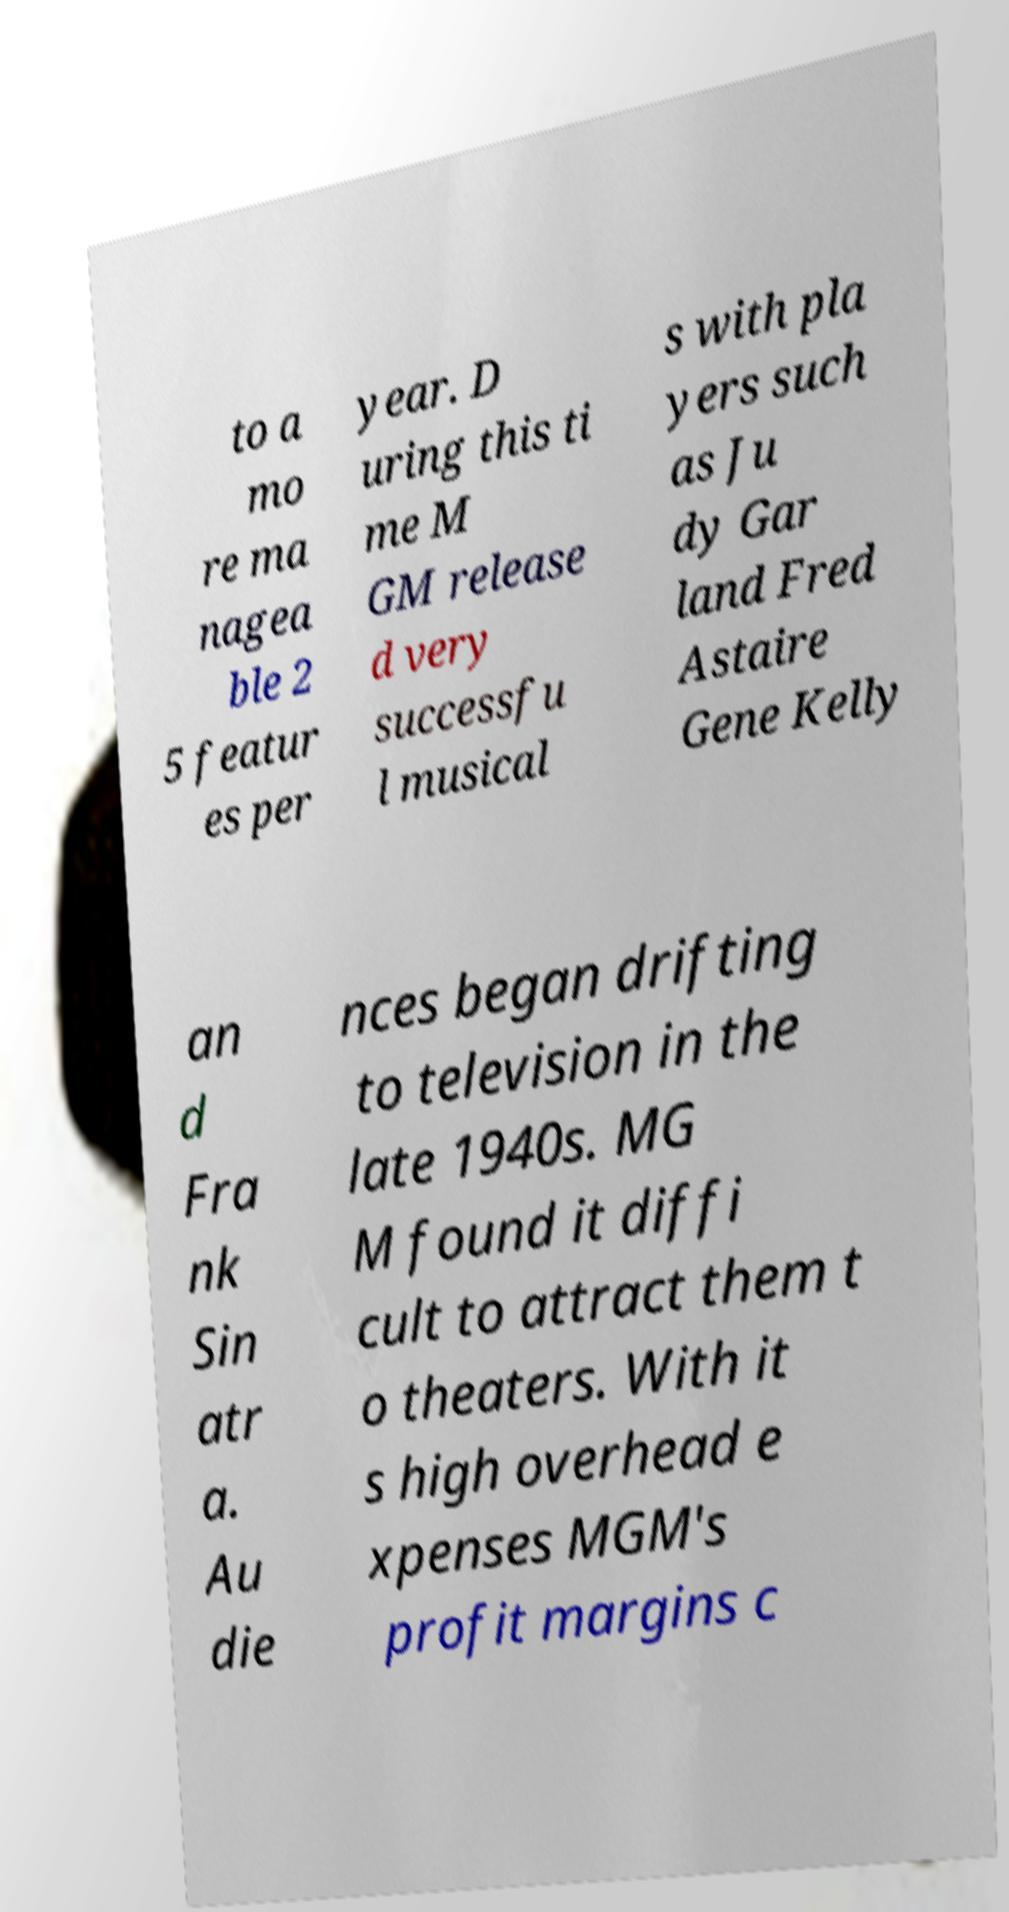Can you accurately transcribe the text from the provided image for me? to a mo re ma nagea ble 2 5 featur es per year. D uring this ti me M GM release d very successfu l musical s with pla yers such as Ju dy Gar land Fred Astaire Gene Kelly an d Fra nk Sin atr a. Au die nces began drifting to television in the late 1940s. MG M found it diffi cult to attract them t o theaters. With it s high overhead e xpenses MGM's profit margins c 